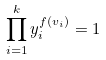<formula> <loc_0><loc_0><loc_500><loc_500>\prod _ { i = 1 } ^ { k } y _ { i } ^ { f ( v _ { i } ) } = 1</formula> 